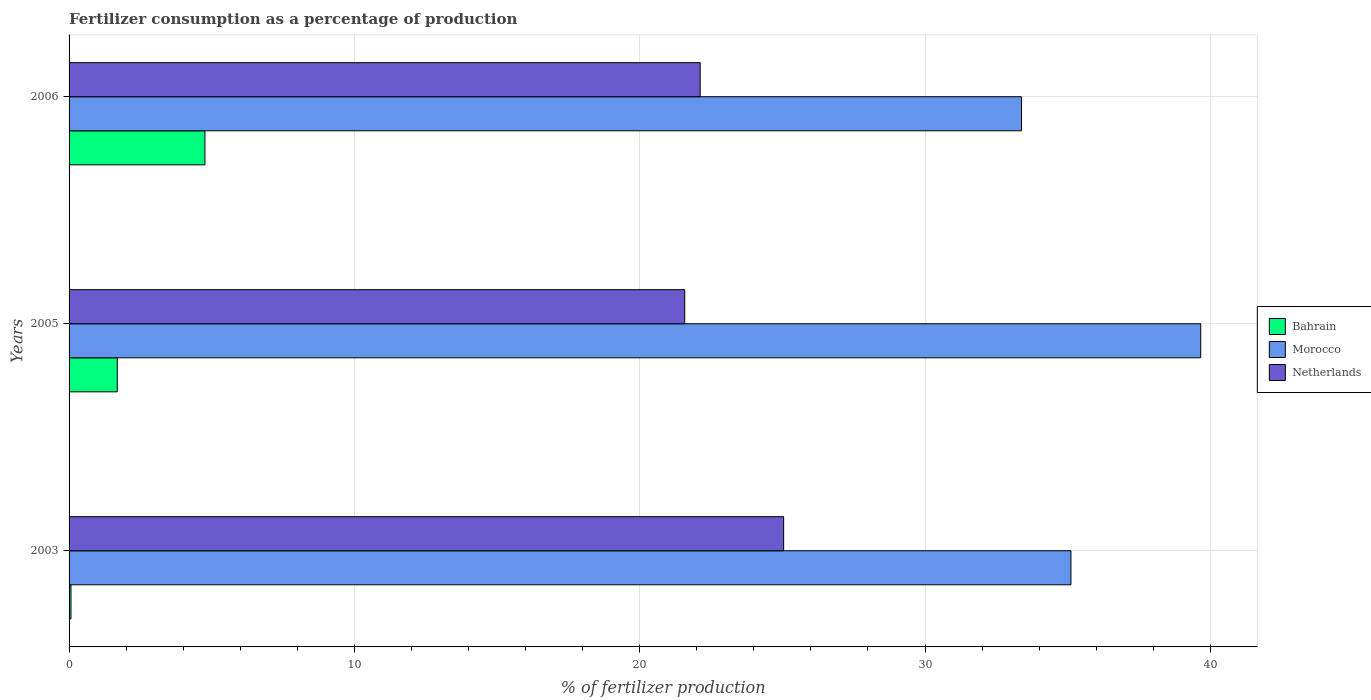How many groups of bars are there?
Offer a very short reply. 3. Are the number of bars per tick equal to the number of legend labels?
Your answer should be compact. Yes. What is the label of the 3rd group of bars from the top?
Provide a short and direct response. 2003. What is the percentage of fertilizers consumed in Netherlands in 2003?
Keep it short and to the point. 25.04. Across all years, what is the maximum percentage of fertilizers consumed in Bahrain?
Provide a succinct answer. 4.76. Across all years, what is the minimum percentage of fertilizers consumed in Netherlands?
Offer a very short reply. 21.58. In which year was the percentage of fertilizers consumed in Bahrain minimum?
Your response must be concise. 2003. What is the total percentage of fertilizers consumed in Bahrain in the graph?
Your response must be concise. 6.52. What is the difference between the percentage of fertilizers consumed in Netherlands in 2005 and that in 2006?
Your response must be concise. -0.54. What is the difference between the percentage of fertilizers consumed in Morocco in 2006 and the percentage of fertilizers consumed in Netherlands in 2003?
Keep it short and to the point. 8.34. What is the average percentage of fertilizers consumed in Morocco per year?
Your answer should be very brief. 36.05. In the year 2003, what is the difference between the percentage of fertilizers consumed in Netherlands and percentage of fertilizers consumed in Bahrain?
Provide a short and direct response. 24.98. What is the ratio of the percentage of fertilizers consumed in Bahrain in 2005 to that in 2006?
Your answer should be very brief. 0.35. Is the percentage of fertilizers consumed in Morocco in 2003 less than that in 2005?
Offer a terse response. Yes. What is the difference between the highest and the second highest percentage of fertilizers consumed in Bahrain?
Keep it short and to the point. 3.07. What is the difference between the highest and the lowest percentage of fertilizers consumed in Netherlands?
Provide a succinct answer. 3.47. Is the sum of the percentage of fertilizers consumed in Morocco in 2003 and 2005 greater than the maximum percentage of fertilizers consumed in Netherlands across all years?
Your response must be concise. Yes. What does the 3rd bar from the top in 2003 represents?
Give a very brief answer. Bahrain. What does the 3rd bar from the bottom in 2003 represents?
Ensure brevity in your answer.  Netherlands. Is it the case that in every year, the sum of the percentage of fertilizers consumed in Netherlands and percentage of fertilizers consumed in Morocco is greater than the percentage of fertilizers consumed in Bahrain?
Your answer should be compact. Yes. Are all the bars in the graph horizontal?
Offer a very short reply. Yes. How many years are there in the graph?
Keep it short and to the point. 3. What is the difference between two consecutive major ticks on the X-axis?
Keep it short and to the point. 10. Does the graph contain any zero values?
Keep it short and to the point. No. Does the graph contain grids?
Provide a succinct answer. Yes. What is the title of the graph?
Offer a terse response. Fertilizer consumption as a percentage of production. What is the label or title of the X-axis?
Provide a short and direct response. % of fertilizer production. What is the % of fertilizer production in Bahrain in 2003?
Your answer should be very brief. 0.07. What is the % of fertilizer production in Morocco in 2003?
Your answer should be compact. 35.11. What is the % of fertilizer production in Netherlands in 2003?
Give a very brief answer. 25.04. What is the % of fertilizer production of Bahrain in 2005?
Give a very brief answer. 1.69. What is the % of fertilizer production of Morocco in 2005?
Give a very brief answer. 39.66. What is the % of fertilizer production in Netherlands in 2005?
Ensure brevity in your answer.  21.58. What is the % of fertilizer production in Bahrain in 2006?
Give a very brief answer. 4.76. What is the % of fertilizer production in Morocco in 2006?
Keep it short and to the point. 33.38. What is the % of fertilizer production of Netherlands in 2006?
Keep it short and to the point. 22.12. Across all years, what is the maximum % of fertilizer production of Bahrain?
Provide a short and direct response. 4.76. Across all years, what is the maximum % of fertilizer production of Morocco?
Ensure brevity in your answer.  39.66. Across all years, what is the maximum % of fertilizer production of Netherlands?
Your response must be concise. 25.04. Across all years, what is the minimum % of fertilizer production of Bahrain?
Provide a succinct answer. 0.07. Across all years, what is the minimum % of fertilizer production of Morocco?
Keep it short and to the point. 33.38. Across all years, what is the minimum % of fertilizer production in Netherlands?
Offer a very short reply. 21.58. What is the total % of fertilizer production of Bahrain in the graph?
Make the answer very short. 6.52. What is the total % of fertilizer production of Morocco in the graph?
Your response must be concise. 108.16. What is the total % of fertilizer production in Netherlands in the graph?
Give a very brief answer. 68.74. What is the difference between the % of fertilizer production in Bahrain in 2003 and that in 2005?
Your answer should be compact. -1.62. What is the difference between the % of fertilizer production in Morocco in 2003 and that in 2005?
Give a very brief answer. -4.55. What is the difference between the % of fertilizer production in Netherlands in 2003 and that in 2005?
Ensure brevity in your answer.  3.47. What is the difference between the % of fertilizer production of Bahrain in 2003 and that in 2006?
Make the answer very short. -4.69. What is the difference between the % of fertilizer production of Morocco in 2003 and that in 2006?
Your answer should be compact. 1.73. What is the difference between the % of fertilizer production in Netherlands in 2003 and that in 2006?
Your answer should be very brief. 2.92. What is the difference between the % of fertilizer production of Bahrain in 2005 and that in 2006?
Offer a terse response. -3.07. What is the difference between the % of fertilizer production of Morocco in 2005 and that in 2006?
Provide a succinct answer. 6.28. What is the difference between the % of fertilizer production in Netherlands in 2005 and that in 2006?
Make the answer very short. -0.54. What is the difference between the % of fertilizer production of Bahrain in 2003 and the % of fertilizer production of Morocco in 2005?
Keep it short and to the point. -39.59. What is the difference between the % of fertilizer production of Bahrain in 2003 and the % of fertilizer production of Netherlands in 2005?
Give a very brief answer. -21.51. What is the difference between the % of fertilizer production in Morocco in 2003 and the % of fertilizer production in Netherlands in 2005?
Offer a terse response. 13.54. What is the difference between the % of fertilizer production of Bahrain in 2003 and the % of fertilizer production of Morocco in 2006?
Make the answer very short. -33.31. What is the difference between the % of fertilizer production of Bahrain in 2003 and the % of fertilizer production of Netherlands in 2006?
Ensure brevity in your answer.  -22.05. What is the difference between the % of fertilizer production in Morocco in 2003 and the % of fertilizer production in Netherlands in 2006?
Offer a terse response. 12.99. What is the difference between the % of fertilizer production of Bahrain in 2005 and the % of fertilizer production of Morocco in 2006?
Give a very brief answer. -31.69. What is the difference between the % of fertilizer production of Bahrain in 2005 and the % of fertilizer production of Netherlands in 2006?
Give a very brief answer. -20.43. What is the difference between the % of fertilizer production in Morocco in 2005 and the % of fertilizer production in Netherlands in 2006?
Provide a short and direct response. 17.54. What is the average % of fertilizer production in Bahrain per year?
Provide a short and direct response. 2.17. What is the average % of fertilizer production in Morocco per year?
Give a very brief answer. 36.05. What is the average % of fertilizer production in Netherlands per year?
Your response must be concise. 22.91. In the year 2003, what is the difference between the % of fertilizer production in Bahrain and % of fertilizer production in Morocco?
Offer a terse response. -35.05. In the year 2003, what is the difference between the % of fertilizer production in Bahrain and % of fertilizer production in Netherlands?
Your answer should be compact. -24.98. In the year 2003, what is the difference between the % of fertilizer production in Morocco and % of fertilizer production in Netherlands?
Provide a succinct answer. 10.07. In the year 2005, what is the difference between the % of fertilizer production in Bahrain and % of fertilizer production in Morocco?
Keep it short and to the point. -37.97. In the year 2005, what is the difference between the % of fertilizer production in Bahrain and % of fertilizer production in Netherlands?
Offer a very short reply. -19.89. In the year 2005, what is the difference between the % of fertilizer production in Morocco and % of fertilizer production in Netherlands?
Provide a short and direct response. 18.08. In the year 2006, what is the difference between the % of fertilizer production in Bahrain and % of fertilizer production in Morocco?
Provide a succinct answer. -28.62. In the year 2006, what is the difference between the % of fertilizer production of Bahrain and % of fertilizer production of Netherlands?
Provide a short and direct response. -17.36. In the year 2006, what is the difference between the % of fertilizer production of Morocco and % of fertilizer production of Netherlands?
Offer a very short reply. 11.26. What is the ratio of the % of fertilizer production in Bahrain in 2003 to that in 2005?
Your answer should be very brief. 0.04. What is the ratio of the % of fertilizer production of Morocco in 2003 to that in 2005?
Offer a terse response. 0.89. What is the ratio of the % of fertilizer production in Netherlands in 2003 to that in 2005?
Provide a short and direct response. 1.16. What is the ratio of the % of fertilizer production in Bahrain in 2003 to that in 2006?
Offer a very short reply. 0.01. What is the ratio of the % of fertilizer production of Morocco in 2003 to that in 2006?
Make the answer very short. 1.05. What is the ratio of the % of fertilizer production in Netherlands in 2003 to that in 2006?
Your answer should be very brief. 1.13. What is the ratio of the % of fertilizer production in Bahrain in 2005 to that in 2006?
Offer a very short reply. 0.35. What is the ratio of the % of fertilizer production in Morocco in 2005 to that in 2006?
Your answer should be compact. 1.19. What is the ratio of the % of fertilizer production in Netherlands in 2005 to that in 2006?
Your response must be concise. 0.98. What is the difference between the highest and the second highest % of fertilizer production of Bahrain?
Ensure brevity in your answer.  3.07. What is the difference between the highest and the second highest % of fertilizer production of Morocco?
Your response must be concise. 4.55. What is the difference between the highest and the second highest % of fertilizer production in Netherlands?
Your response must be concise. 2.92. What is the difference between the highest and the lowest % of fertilizer production of Bahrain?
Your response must be concise. 4.69. What is the difference between the highest and the lowest % of fertilizer production of Morocco?
Keep it short and to the point. 6.28. What is the difference between the highest and the lowest % of fertilizer production in Netherlands?
Keep it short and to the point. 3.47. 